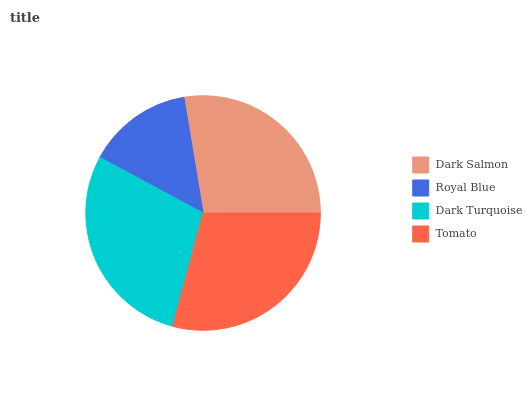Is Royal Blue the minimum?
Answer yes or no. Yes. Is Tomato the maximum?
Answer yes or no. Yes. Is Dark Turquoise the minimum?
Answer yes or no. No. Is Dark Turquoise the maximum?
Answer yes or no. No. Is Dark Turquoise greater than Royal Blue?
Answer yes or no. Yes. Is Royal Blue less than Dark Turquoise?
Answer yes or no. Yes. Is Royal Blue greater than Dark Turquoise?
Answer yes or no. No. Is Dark Turquoise less than Royal Blue?
Answer yes or no. No. Is Dark Turquoise the high median?
Answer yes or no. Yes. Is Dark Salmon the low median?
Answer yes or no. Yes. Is Tomato the high median?
Answer yes or no. No. Is Royal Blue the low median?
Answer yes or no. No. 